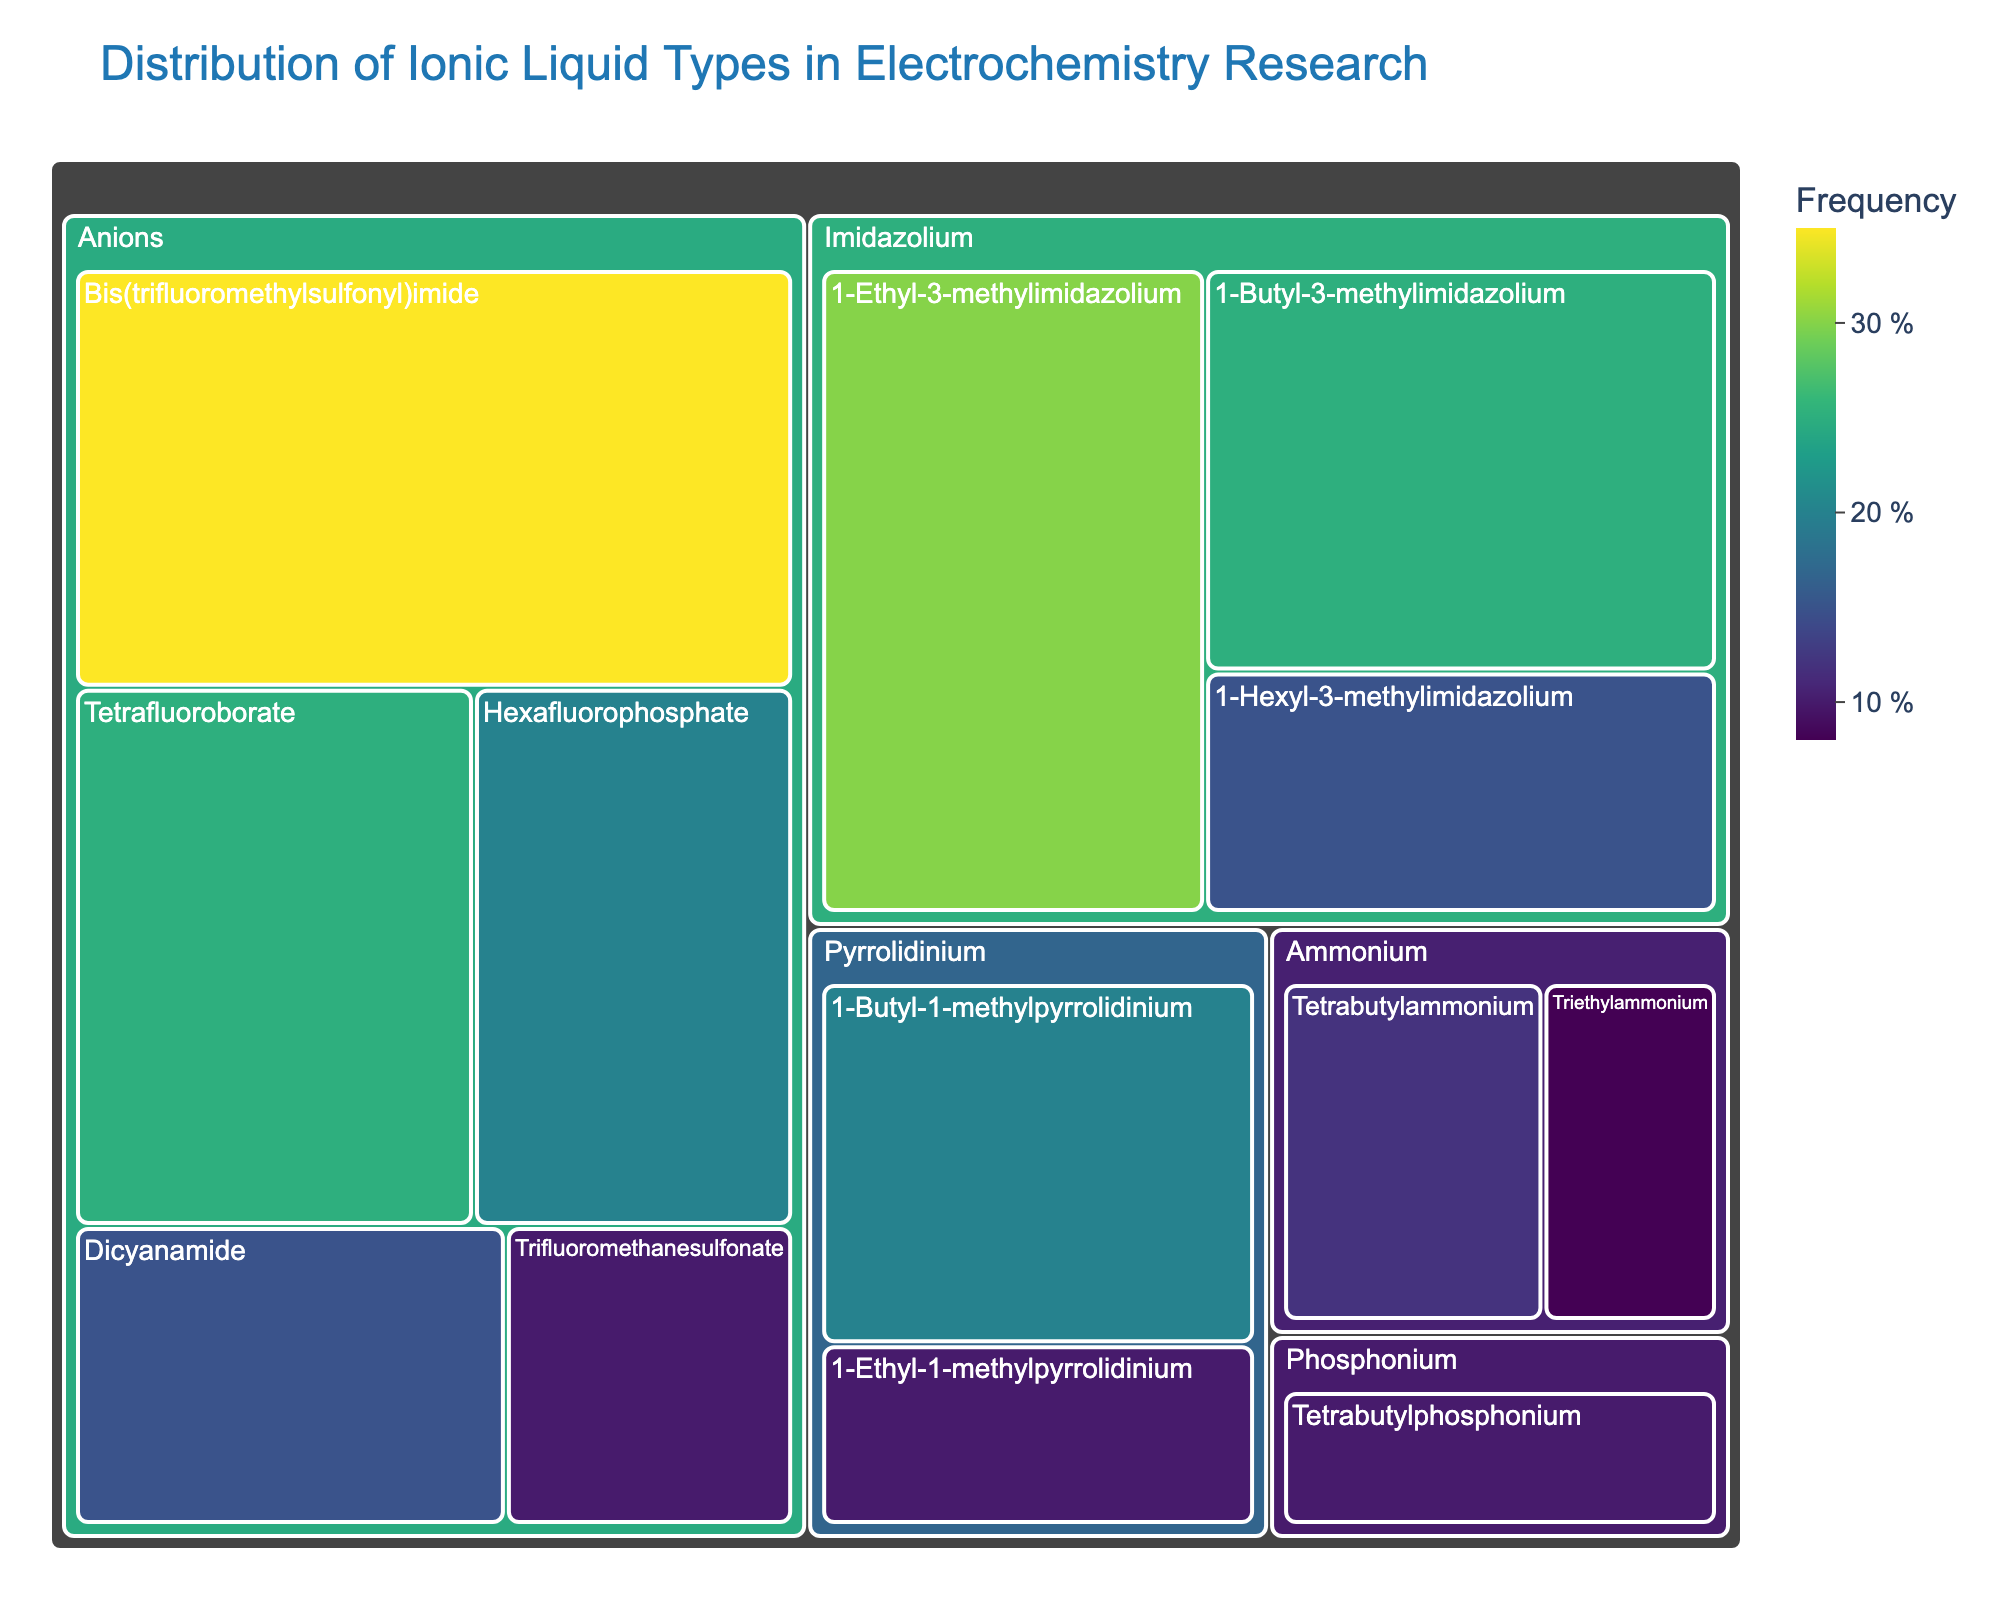What are the three subcategories under "Imidazolium"? The subcategories under "Imidazolium" can be identified from the treemap as: 1-Ethyl-3-methylimidazolium, 1-Butyl-3-methylimidazolium, and 1-Hexyl-3-methylimidazolium.
Answer: 1-Ethyl-3-methylimidazolium, 1-Butyl-3-methylimidazolium, 1-Hexyl-3-methylimidazolium Which "Anion" has the highest value? To find the anion with the highest value, look at the subcategories under the "Anions" category and identify the one with the largest area. Bis(trifluoromethylsulfonyl)imide has the highest value at 35.
Answer: Bis(trifluoromethylsulfonyl)imide What is the total value for the "Ammonium" category? Sum the values of all subcategories under the "Ammonium" category: Tetrabutylammonium (12) and Triethylammonium (8). The total is 12 + 8 = 20.
Answer: 20 Compare the values of "1-Butyl-3-methylimidazolium" and "1-Hexyl-3-methylimidazolium". Which one has a higher value? Look at the values for 1-Butyl-3-methylimidazolium (25) and 1-Hexyl-3-methylimidazolium (15). 1-Butyl-3-methylimidazolium has a higher value.
Answer: 1-Butyl-3-methylimidazolium How much greater is the value of "Bis(trifluoromethylsulfonyl)imide" compared to "Hexafluorophosphate"? Subtract the value of Hexafluorophosphate (20) from Bis(trifluoromethylsulfonyl)imide (35): 35 - 20 = 15.
Answer: 15 What is the title of the treemap? The title is located at the top of the treemap and reads "Distribution of Ionic Liquid Types in Electrochemistry Research".
Answer: Distribution of Ionic Liquid Types in Electrochemistry Research Which subcategory under "Pyrrolidinium" has a lower value? Compare the values of 1-Butyl-1-methylpyrrolidinium (20) and 1-Ethyl-1-methylpyrrolidinium (10). 1-Ethyl-1-methylpyrrolidinium has a lower value.
Answer: 1-Ethyl-1-methylpyrrolidinium What is the total value represented by the "Anions" category? Sum the values of all anion subcategories: Bis(trifluoromethylsulfonyl)imide (35), Tetrafluoroborate (25), Hexafluorophosphate (20), Dicyanamide (15), Trifluoromethanesulfonate (10). The total is 35 + 25 + 20 + 15 + 10 = 105.
Answer: 105 How many main categories are displayed in the treemap? Count the main categories shown in the treemap: Imidazolium, Pyrrolidinium, Ammonium, Phosphonium, Anions. There are 5 main categories.
Answer: 5 